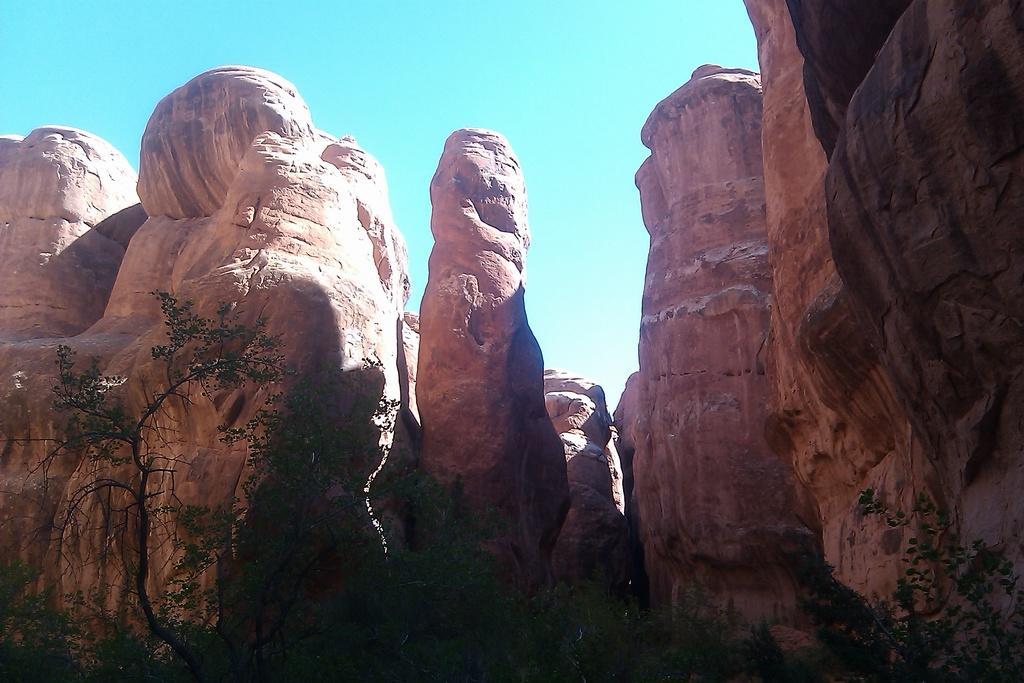In one or two sentences, can you explain what this image depicts? In this picture I can see trees in the foreground. I can see the rocks. I can see clouds in the sky. 